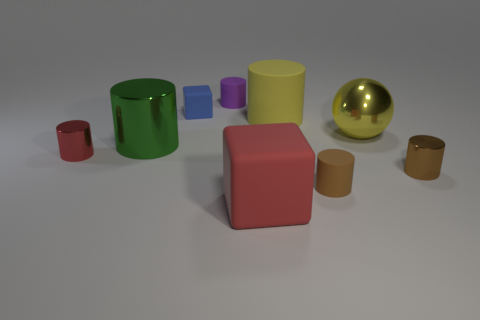Can you tell me how many objects in the image are not cylinders? In the image, there are three objects that are not cylinders: one golden sphere, one red cube, and one tan cuboid. 